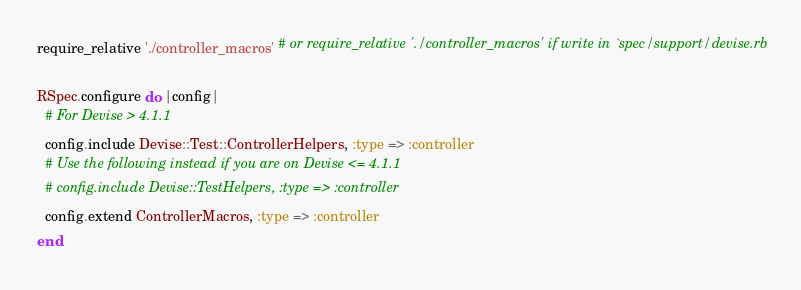Convert code to text. <code><loc_0><loc_0><loc_500><loc_500><_Ruby_>require_relative './controller_macros' # or require_relative './controller_macros' if write in `spec/support/devise.rb

RSpec.configure do |config|
  # For Devise > 4.1.1
  config.include Devise::Test::ControllerHelpers, :type => :controller
  # Use the following instead if you are on Devise <= 4.1.1
  # config.include Devise::TestHelpers, :type => :controller
  config.extend ControllerMacros, :type => :controller
end
</code> 